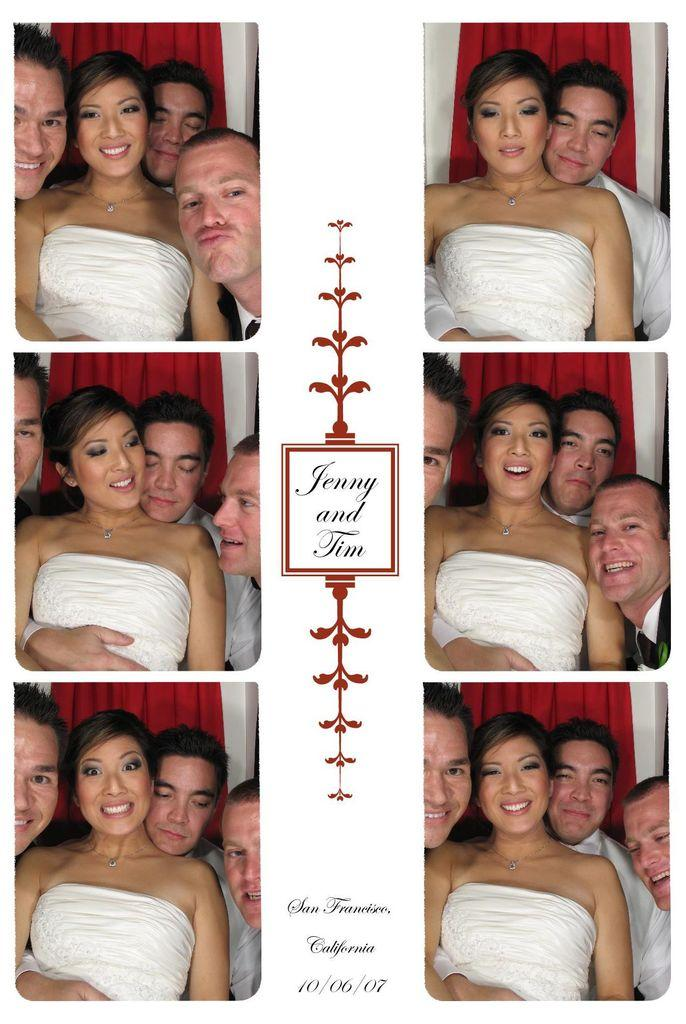How many people are visible in the image? There are many people in the image. What type of image is this? The image appears to be a collage. Can you describe a specific person in the image? There is a woman wearing a white dress in the image, and she is stunning. What else can be found in the middle of the image? There is text in the middle of the image. What type of silver object can be seen in the woman's hand in the image? There is no silver object visible in the woman's hand in the image. What time of day is it in the image? The time of day cannot be determined from the image, as there are no specific clues or indicators. 